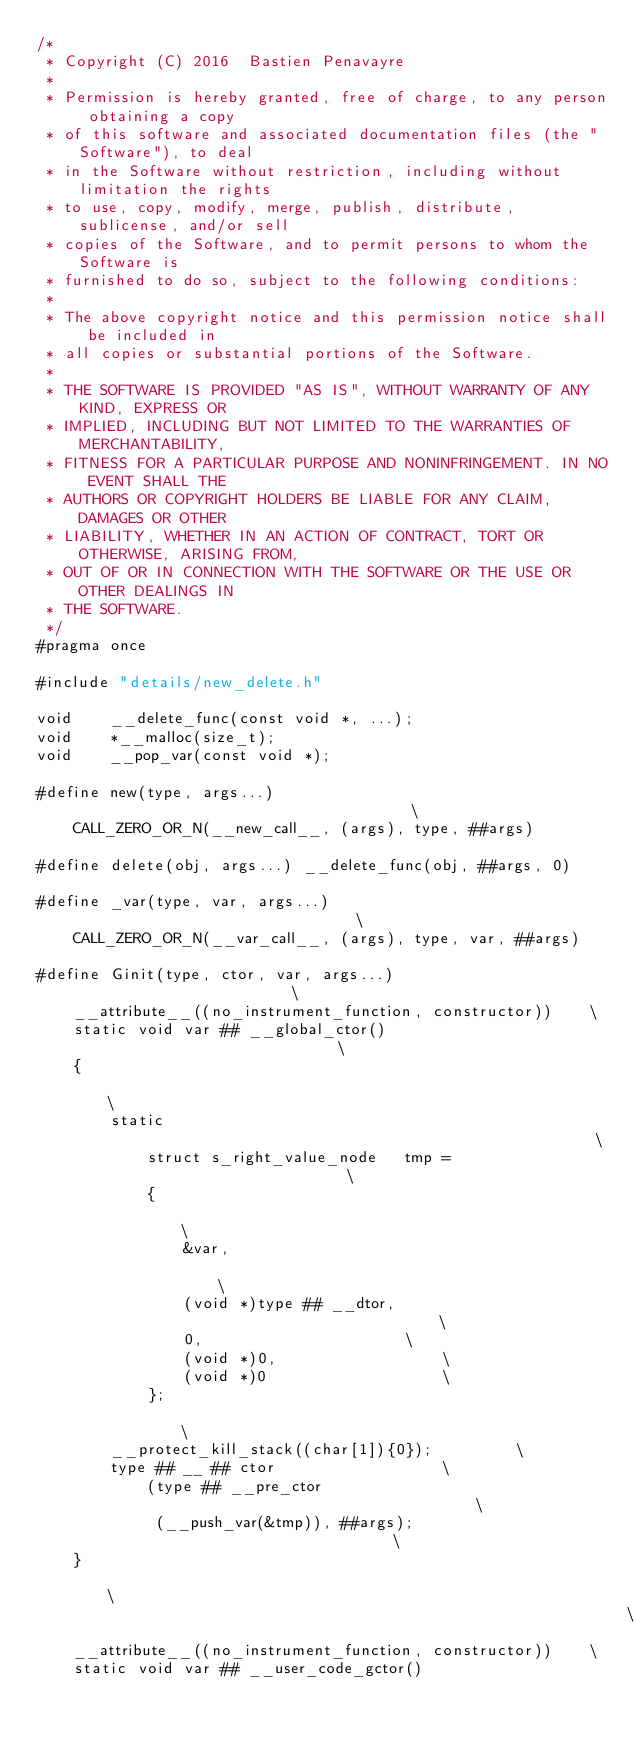Convert code to text. <code><loc_0><loc_0><loc_500><loc_500><_C_>/*
 * Copyright (C) 2016  Bastien Penavayre
 *
 * Permission is hereby granted, free of charge, to any person obtaining a copy
 * of this software and associated documentation files (the "Software"), to deal
 * in the Software without restriction, including without limitation the rights
 * to use, copy, modify, merge, publish, distribute, sublicense, and/or sell
 * copies of the Software, and to permit persons to whom the Software is
 * furnished to do so, subject to the following conditions:
 *
 * The above copyright notice and this permission notice shall be included in
 * all copies or substantial portions of the Software.
 *
 * THE SOFTWARE IS PROVIDED "AS IS", WITHOUT WARRANTY OF ANY KIND, EXPRESS OR
 * IMPLIED, INCLUDING BUT NOT LIMITED TO THE WARRANTIES OF MERCHANTABILITY,
 * FITNESS FOR A PARTICULAR PURPOSE AND NONINFRINGEMENT. IN NO EVENT SHALL THE
 * AUTHORS OR COPYRIGHT HOLDERS BE LIABLE FOR ANY CLAIM, DAMAGES OR OTHER
 * LIABILITY, WHETHER IN AN ACTION OF CONTRACT, TORT OR OTHERWISE, ARISING FROM,
 * OUT OF OR IN CONNECTION WITH THE SOFTWARE OR THE USE OR OTHER DEALINGS IN
 * THE SOFTWARE.
 */
#pragma once

#include "details/new_delete.h"

void	__delete_func(const void *, ...);
void	*__malloc(size_t);
void    __pop_var(const void *);

#define new(type, args...)                                      \
    CALL_ZERO_OR_N(__new_call__, (args), type, ##args)

#define delete(obj, args...) __delete_func(obj, ##args, 0)

#define _var(type, var, args...)                                \
    CALL_ZERO_OR_N(__var_call__, (args), type, var, ##args)

#define Ginit(type, ctor, var, args...)                         \
    __attribute__((no_instrument_function, constructor))	\
    static void	var ## __global_ctor()                          \
    {                                                           \
        static                                                  \
            struct s_right_value_node	tmp =                   \
            {                                                   \
                &var,                                           \
                (void *)type ## __dtor,                         \
                0,						\
                (void *)0,					\
                (void *)0					\
            };                                                  \
        __protect_kill_stack((char[1]){0});			\
        type ## __ ## ctor					\
            (type ## __pre_ctor                                 \
             (__push_var(&tmp)), ##args);                       \
    }                                                           \
                                                                \
    __attribute__((no_instrument_function, constructor))	\
    static void var ## __user_code_gctor()
</code> 